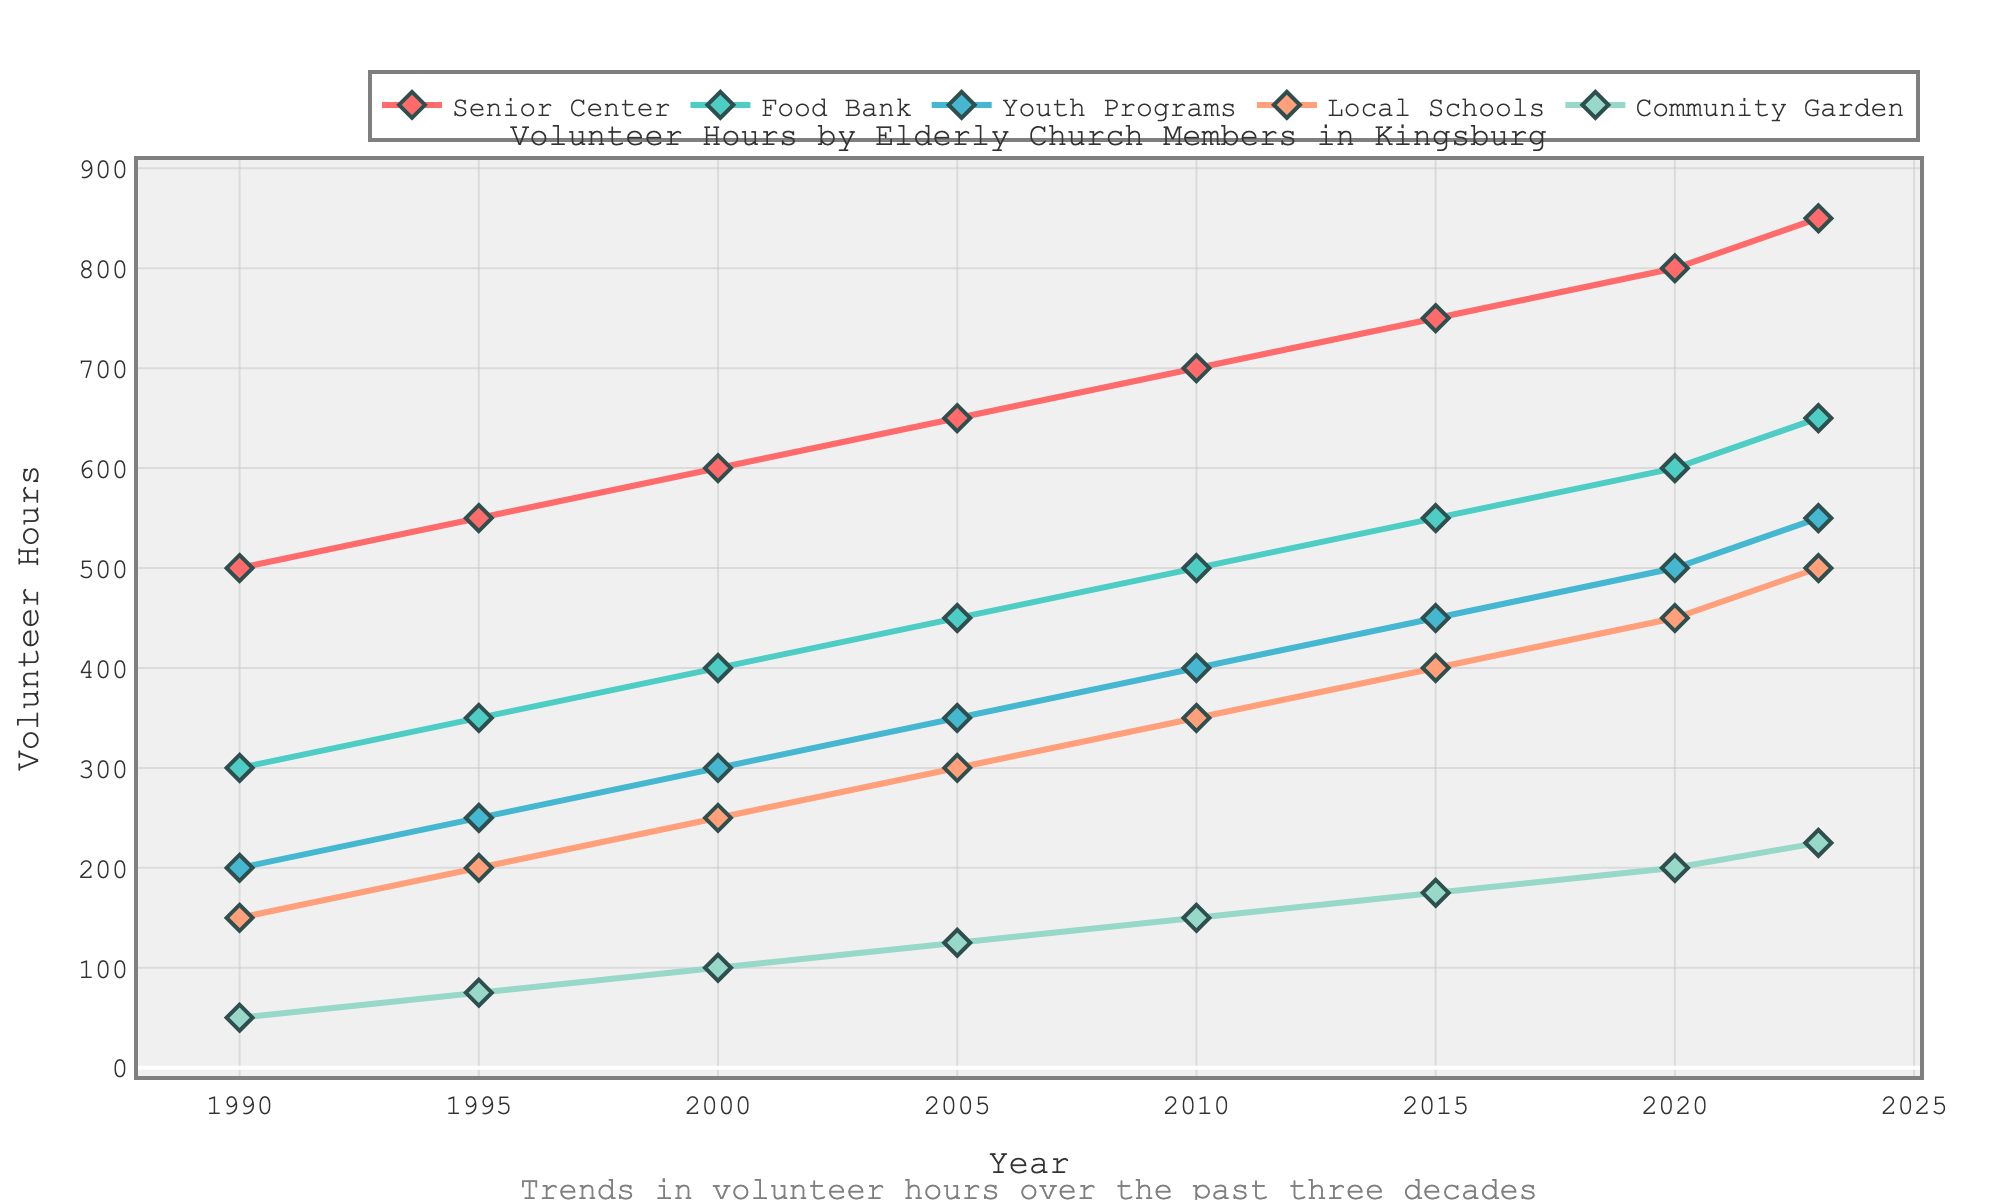What's the trend in volunteer hours at the Senior Center over the last three decades? The line chart for the Senior Center shows a consistent upward trend from 1990 to 2023. Starting at 500 hours in 1990, the volunteer hours increased to 850 by 2023.
Answer: Consistent upward trend Which community service had the highest increase in volunteer hours from 1990 to 2023? By comparing the starting and ending points for each service, the Food Bank increased from 300 to 650 hours, Senior Center from 500 to 850, Youth Programs from 200 to 550, Local Schools from 150 to 500, and Community Garden from 50 to 225 hours. The Senior Center had the highest increase of 350 hours.
Answer: Senior Center What is the total volunteer hours contributed to Local Schools and Youth Programs in 2023? In 2023, Local Schools had 500 hours and Youth Programs had 550 hours; summing them up gives 500 + 550 = 1050 hours.
Answer: 1050 hours Between 2010 and 2015, which service saw the smallest increase in volunteer hours? By observing the increments: Senior Center (700 to 750), Food Bank (500 to 550), Youth Programs (400 to 450), Local Schools (350 to 400), and Community Garden (150 to 175). The smallest increase occurred in the Community Garden, with an increase of 25 hours.
Answer: Community Garden Are there any services where volunteer hours doubled from 1990 to 2023? To determine this, multiply the 1990 values by 2 and compare them to 2023 values: Senior Center (500×2 = 1000, but it's 850), Food Bank (300×2 = 600, exact match to 2023’s 650), Youth Programs (200×2=400, but it's 550), Local Schools (150×2=300, but it's 500), Community Garden (50×2=100, but it's 225). Volunteer hours doubled only for the Food Bank.
Answer: Food Bank Which year had the highest combined total of volunteer hours across all services? Sum the hours for each year: 1990 (1200), 1995 (1425), 2000 (1650), 2005 (1875), 2010 (2100), 2015 (2325), 2020 (2550), 2023 (2775). The combined total is highest in 2023 at 2775 hours.
Answer: 2023 What's the average annual increase in volunteer hours for the Senior Center between 1990 and 2023? Annual increase = (850 hours in 2023 - 500 hours in 1990) / (2023 - 1990) = 350 / 33 ≈ 10.6 hours per year.
Answer: 10.6 hours per year How do the volunteer hours for Youth Programs in 2000 compare to those for Local Schools in the same year? In 2000, Youth Programs had 300 hours and Local Schools had 250 hours, so Youth Programs had 50 more hours than Local Schools.
Answer: 50 more hours 